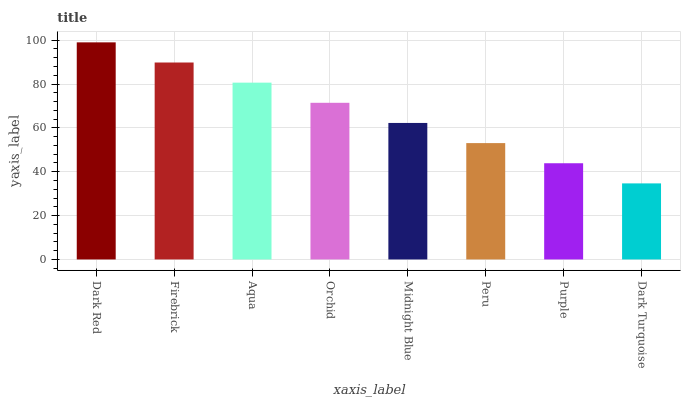Is Dark Turquoise the minimum?
Answer yes or no. Yes. Is Dark Red the maximum?
Answer yes or no. Yes. Is Firebrick the minimum?
Answer yes or no. No. Is Firebrick the maximum?
Answer yes or no. No. Is Dark Red greater than Firebrick?
Answer yes or no. Yes. Is Firebrick less than Dark Red?
Answer yes or no. Yes. Is Firebrick greater than Dark Red?
Answer yes or no. No. Is Dark Red less than Firebrick?
Answer yes or no. No. Is Orchid the high median?
Answer yes or no. Yes. Is Midnight Blue the low median?
Answer yes or no. Yes. Is Dark Turquoise the high median?
Answer yes or no. No. Is Dark Turquoise the low median?
Answer yes or no. No. 